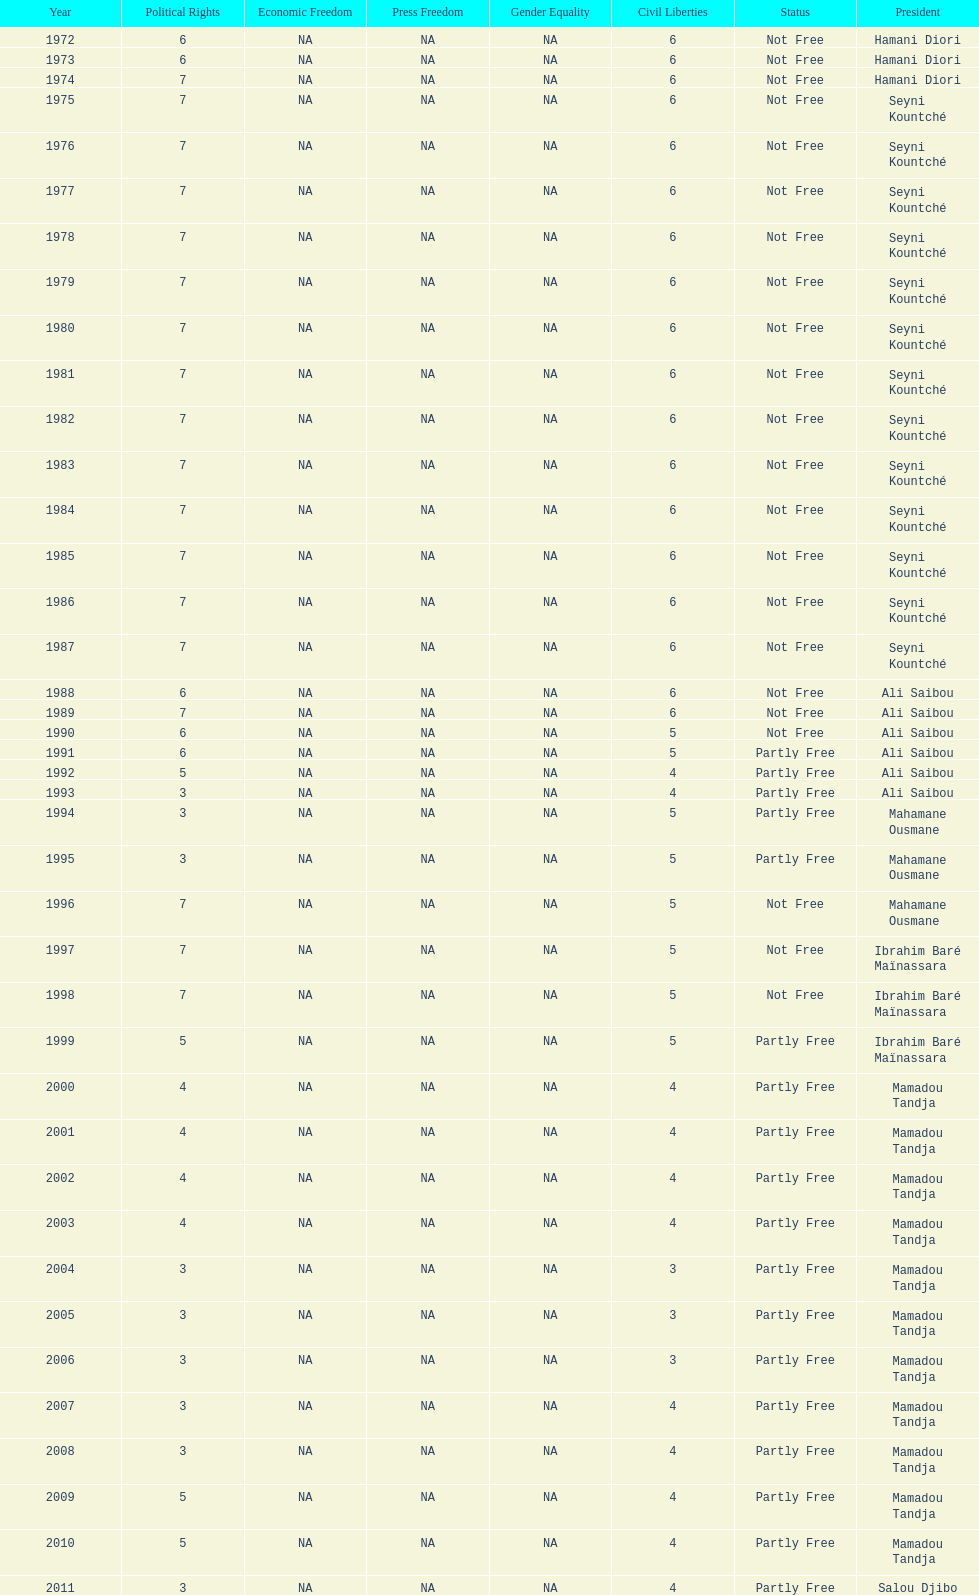Who ruled longer, ali saibou or mamadou tandja? Mamadou Tandja. 